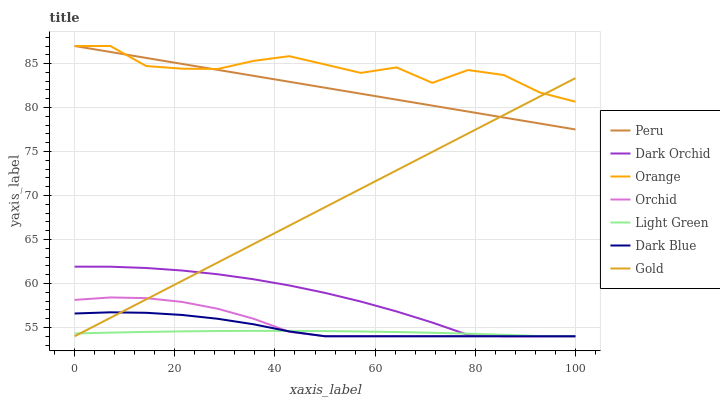Does Gold have the minimum area under the curve?
Answer yes or no. No. Does Gold have the maximum area under the curve?
Answer yes or no. No. Is Gold the smoothest?
Answer yes or no. No. Is Gold the roughest?
Answer yes or no. No. Does Orange have the lowest value?
Answer yes or no. No. Does Gold have the highest value?
Answer yes or no. No. Is Dark Orchid less than Peru?
Answer yes or no. Yes. Is Peru greater than Dark Blue?
Answer yes or no. Yes. Does Dark Orchid intersect Peru?
Answer yes or no. No. 